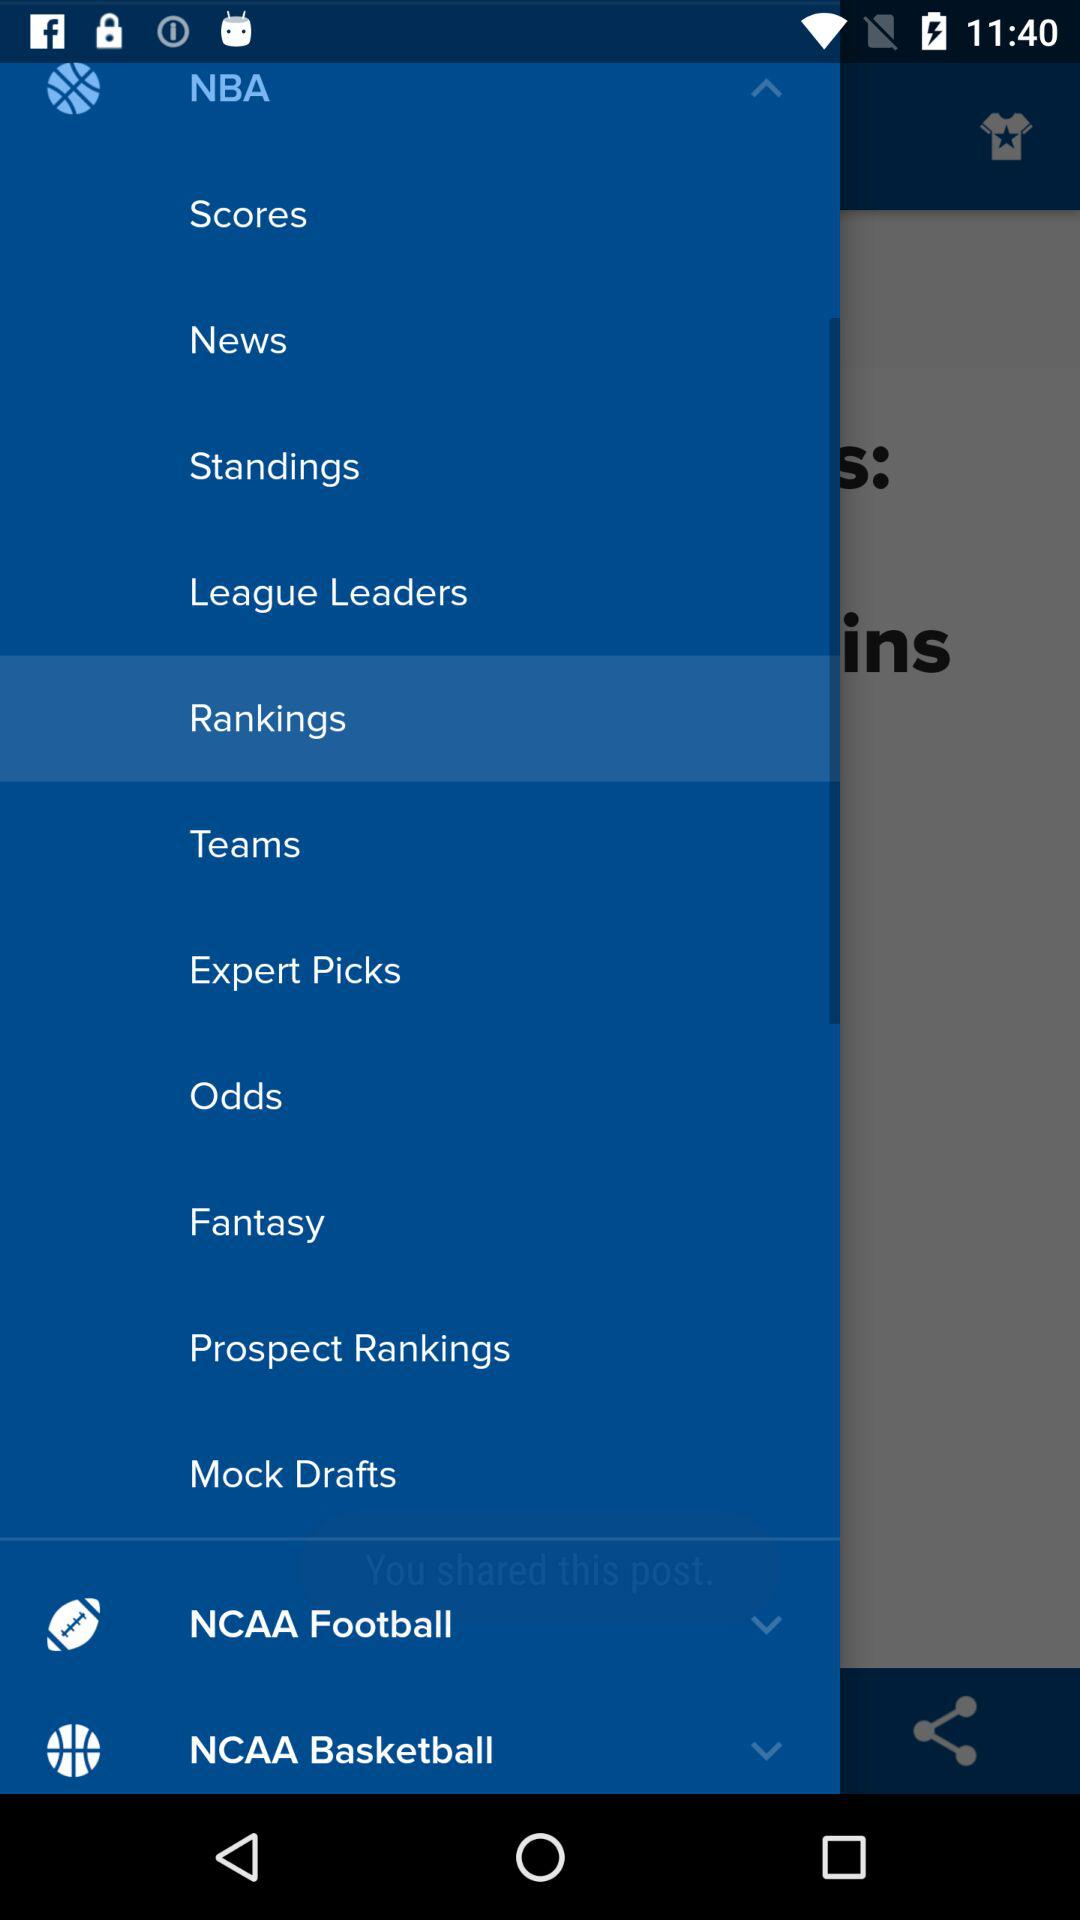What is the selected option? The selected option is "Rankings". 